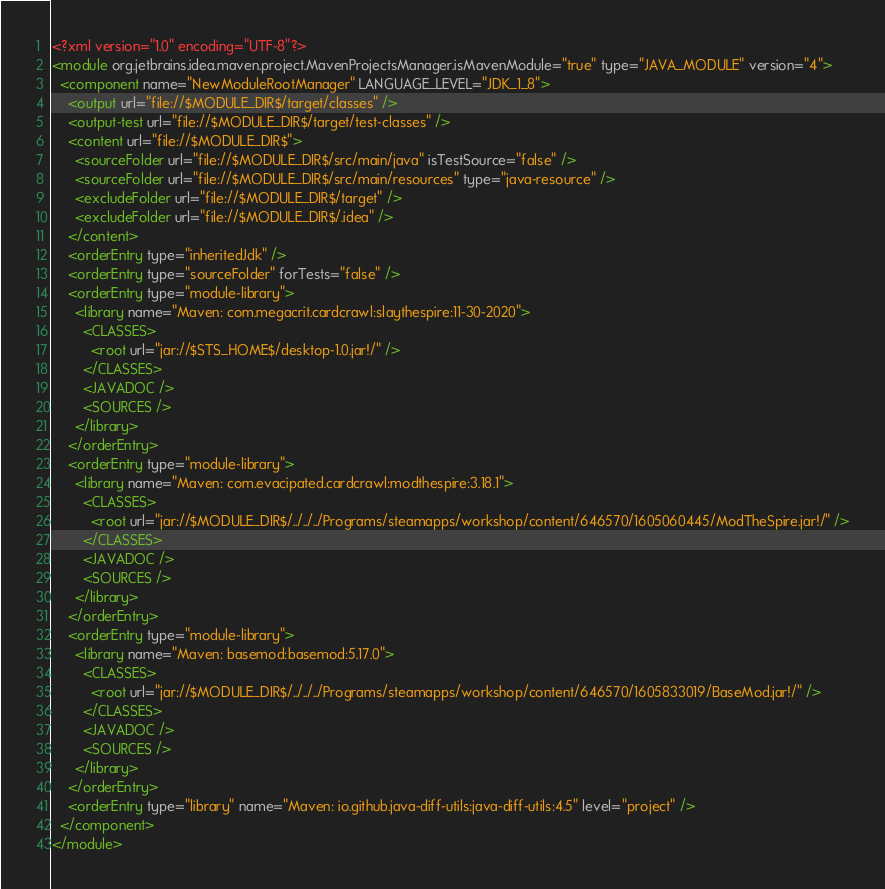Convert code to text. <code><loc_0><loc_0><loc_500><loc_500><_XML_><?xml version="1.0" encoding="UTF-8"?>
<module org.jetbrains.idea.maven.project.MavenProjectsManager.isMavenModule="true" type="JAVA_MODULE" version="4">
  <component name="NewModuleRootManager" LANGUAGE_LEVEL="JDK_1_8">
    <output url="file://$MODULE_DIR$/target/classes" />
    <output-test url="file://$MODULE_DIR$/target/test-classes" />
    <content url="file://$MODULE_DIR$">
      <sourceFolder url="file://$MODULE_DIR$/src/main/java" isTestSource="false" />
      <sourceFolder url="file://$MODULE_DIR$/src/main/resources" type="java-resource" />
      <excludeFolder url="file://$MODULE_DIR$/target" />
      <excludeFolder url="file://$MODULE_DIR$/.idea" />
    </content>
    <orderEntry type="inheritedJdk" />
    <orderEntry type="sourceFolder" forTests="false" />
    <orderEntry type="module-library">
      <library name="Maven: com.megacrit.cardcrawl:slaythespire:11-30-2020">
        <CLASSES>
          <root url="jar://$STS_HOME$/desktop-1.0.jar!/" />
        </CLASSES>
        <JAVADOC />
        <SOURCES />
      </library>
    </orderEntry>
    <orderEntry type="module-library">
      <library name="Maven: com.evacipated.cardcrawl:modthespire:3.18.1">
        <CLASSES>
          <root url="jar://$MODULE_DIR$/../../../Programs/steamapps/workshop/content/646570/1605060445/ModTheSpire.jar!/" />
        </CLASSES>
        <JAVADOC />
        <SOURCES />
      </library>
    </orderEntry>
    <orderEntry type="module-library">
      <library name="Maven: basemod:basemod:5.17.0">
        <CLASSES>
          <root url="jar://$MODULE_DIR$/../../../Programs/steamapps/workshop/content/646570/1605833019/BaseMod.jar!/" />
        </CLASSES>
        <JAVADOC />
        <SOURCES />
      </library>
    </orderEntry>
    <orderEntry type="library" name="Maven: io.github.java-diff-utils:java-diff-utils:4.5" level="project" />
  </component>
</module></code> 